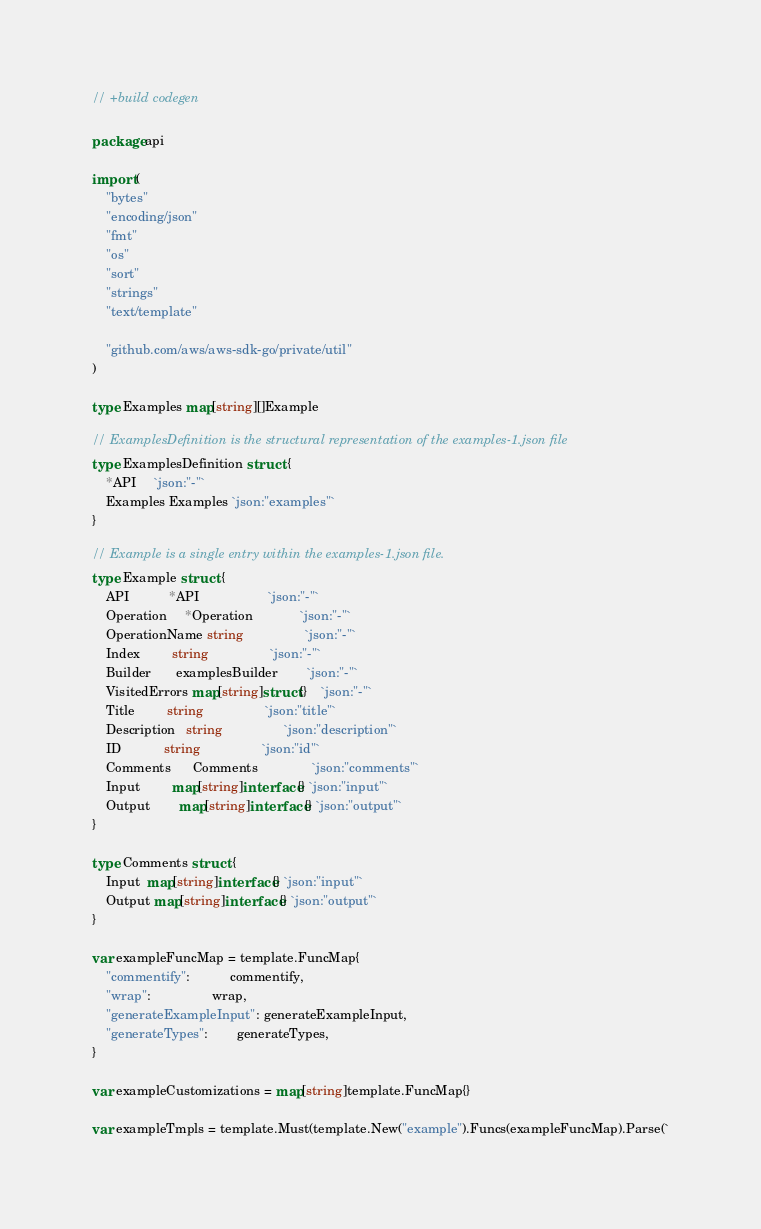Convert code to text. <code><loc_0><loc_0><loc_500><loc_500><_Go_>// +build codegen

package api

import (
	"bytes"
	"encoding/json"
	"fmt"
	"os"
	"sort"
	"strings"
	"text/template"

	"github.com/aws/aws-sdk-go/private/util"
)

type Examples map[string][]Example

// ExamplesDefinition is the structural representation of the examples-1.json file
type ExamplesDefinition struct {
	*API     `json:"-"`
	Examples Examples `json:"examples"`
}

// Example is a single entry within the examples-1.json file.
type Example struct {
	API           *API                   `json:"-"`
	Operation     *Operation             `json:"-"`
	OperationName string                 `json:"-"`
	Index         string                 `json:"-"`
	Builder       examplesBuilder        `json:"-"`
	VisitedErrors map[string]struct{}    `json:"-"`
	Title         string                 `json:"title"`
	Description   string                 `json:"description"`
	ID            string                 `json:"id"`
	Comments      Comments               `json:"comments"`
	Input         map[string]interface{} `json:"input"`
	Output        map[string]interface{} `json:"output"`
}

type Comments struct {
	Input  map[string]interface{} `json:"input"`
	Output map[string]interface{} `json:"output"`
}

var exampleFuncMap = template.FuncMap{
	"commentify":           commentify,
	"wrap":                 wrap,
	"generateExampleInput": generateExampleInput,
	"generateTypes":        generateTypes,
}

var exampleCustomizations = map[string]template.FuncMap{}

var exampleTmpls = template.Must(template.New("example").Funcs(exampleFuncMap).Parse(`</code> 